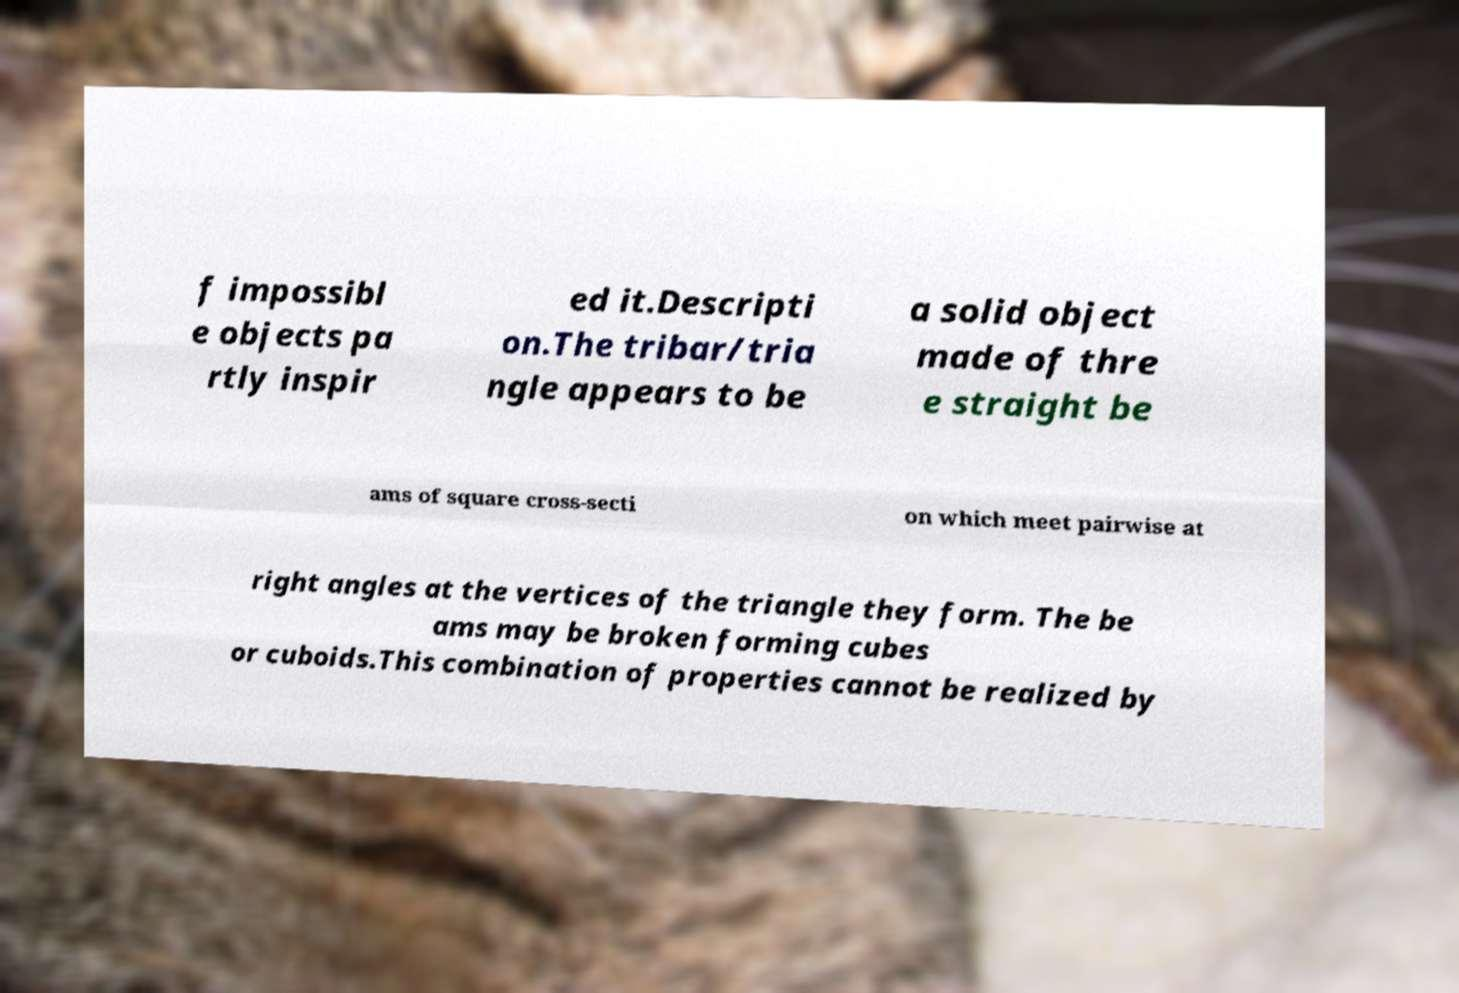Can you read and provide the text displayed in the image?This photo seems to have some interesting text. Can you extract and type it out for me? f impossibl e objects pa rtly inspir ed it.Descripti on.The tribar/tria ngle appears to be a solid object made of thre e straight be ams of square cross-secti on which meet pairwise at right angles at the vertices of the triangle they form. The be ams may be broken forming cubes or cuboids.This combination of properties cannot be realized by 